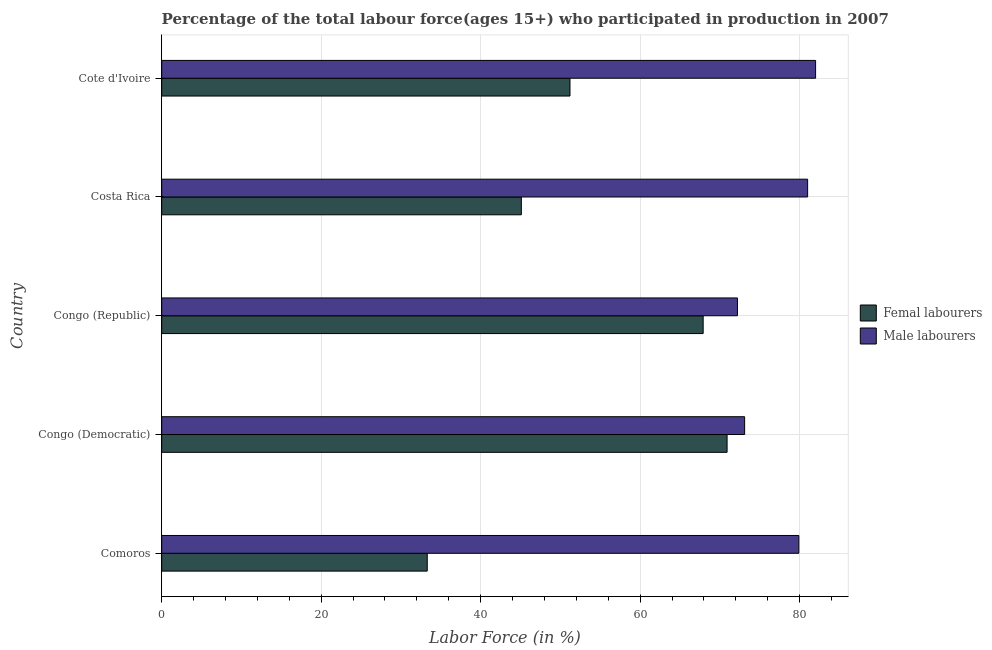How many groups of bars are there?
Keep it short and to the point. 5. Are the number of bars per tick equal to the number of legend labels?
Provide a succinct answer. Yes. How many bars are there on the 1st tick from the top?
Provide a succinct answer. 2. How many bars are there on the 3rd tick from the bottom?
Your answer should be very brief. 2. What is the label of the 2nd group of bars from the top?
Make the answer very short. Costa Rica. In how many cases, is the number of bars for a given country not equal to the number of legend labels?
Keep it short and to the point. 0. What is the percentage of female labor force in Comoros?
Your answer should be compact. 33.3. Across all countries, what is the maximum percentage of male labour force?
Your answer should be very brief. 82. Across all countries, what is the minimum percentage of male labour force?
Give a very brief answer. 72.2. In which country was the percentage of male labour force maximum?
Make the answer very short. Cote d'Ivoire. In which country was the percentage of male labour force minimum?
Give a very brief answer. Congo (Republic). What is the total percentage of male labour force in the graph?
Give a very brief answer. 388.2. What is the difference between the percentage of female labor force in Comoros and that in Congo (Republic)?
Make the answer very short. -34.6. What is the difference between the percentage of male labour force in Congo (Democratic) and the percentage of female labor force in Congo (Republic)?
Offer a very short reply. 5.2. What is the average percentage of male labour force per country?
Keep it short and to the point. 77.64. What is the difference between the percentage of male labour force and percentage of female labor force in Congo (Republic)?
Ensure brevity in your answer.  4.3. Is the percentage of female labor force in Comoros less than that in Congo (Democratic)?
Keep it short and to the point. Yes. Is the difference between the percentage of female labor force in Comoros and Congo (Republic) greater than the difference between the percentage of male labour force in Comoros and Congo (Republic)?
Offer a terse response. No. In how many countries, is the percentage of female labor force greater than the average percentage of female labor force taken over all countries?
Provide a succinct answer. 2. What does the 1st bar from the top in Cote d'Ivoire represents?
Keep it short and to the point. Male labourers. What does the 1st bar from the bottom in Congo (Democratic) represents?
Offer a terse response. Femal labourers. How many bars are there?
Your response must be concise. 10. Are all the bars in the graph horizontal?
Provide a succinct answer. Yes. What is the difference between two consecutive major ticks on the X-axis?
Offer a very short reply. 20. Does the graph contain grids?
Offer a terse response. Yes. How are the legend labels stacked?
Your response must be concise. Vertical. What is the title of the graph?
Offer a terse response. Percentage of the total labour force(ages 15+) who participated in production in 2007. Does "Canada" appear as one of the legend labels in the graph?
Offer a terse response. No. What is the label or title of the Y-axis?
Your answer should be very brief. Country. What is the Labor Force (in %) in Femal labourers in Comoros?
Give a very brief answer. 33.3. What is the Labor Force (in %) of Male labourers in Comoros?
Make the answer very short. 79.9. What is the Labor Force (in %) in Femal labourers in Congo (Democratic)?
Give a very brief answer. 70.9. What is the Labor Force (in %) of Male labourers in Congo (Democratic)?
Your answer should be very brief. 73.1. What is the Labor Force (in %) in Femal labourers in Congo (Republic)?
Offer a very short reply. 67.9. What is the Labor Force (in %) of Male labourers in Congo (Republic)?
Your response must be concise. 72.2. What is the Labor Force (in %) in Femal labourers in Costa Rica?
Ensure brevity in your answer.  45.1. What is the Labor Force (in %) in Male labourers in Costa Rica?
Your response must be concise. 81. What is the Labor Force (in %) of Femal labourers in Cote d'Ivoire?
Provide a short and direct response. 51.2. Across all countries, what is the maximum Labor Force (in %) in Femal labourers?
Your answer should be compact. 70.9. Across all countries, what is the maximum Labor Force (in %) of Male labourers?
Your answer should be very brief. 82. Across all countries, what is the minimum Labor Force (in %) of Femal labourers?
Make the answer very short. 33.3. Across all countries, what is the minimum Labor Force (in %) in Male labourers?
Your response must be concise. 72.2. What is the total Labor Force (in %) in Femal labourers in the graph?
Your response must be concise. 268.4. What is the total Labor Force (in %) of Male labourers in the graph?
Offer a terse response. 388.2. What is the difference between the Labor Force (in %) of Femal labourers in Comoros and that in Congo (Democratic)?
Offer a terse response. -37.6. What is the difference between the Labor Force (in %) in Male labourers in Comoros and that in Congo (Democratic)?
Provide a succinct answer. 6.8. What is the difference between the Labor Force (in %) of Femal labourers in Comoros and that in Congo (Republic)?
Provide a succinct answer. -34.6. What is the difference between the Labor Force (in %) of Male labourers in Comoros and that in Congo (Republic)?
Ensure brevity in your answer.  7.7. What is the difference between the Labor Force (in %) in Femal labourers in Comoros and that in Cote d'Ivoire?
Make the answer very short. -17.9. What is the difference between the Labor Force (in %) in Male labourers in Congo (Democratic) and that in Congo (Republic)?
Ensure brevity in your answer.  0.9. What is the difference between the Labor Force (in %) of Femal labourers in Congo (Democratic) and that in Costa Rica?
Make the answer very short. 25.8. What is the difference between the Labor Force (in %) of Male labourers in Congo (Democratic) and that in Costa Rica?
Provide a succinct answer. -7.9. What is the difference between the Labor Force (in %) in Male labourers in Congo (Democratic) and that in Cote d'Ivoire?
Offer a very short reply. -8.9. What is the difference between the Labor Force (in %) of Femal labourers in Congo (Republic) and that in Costa Rica?
Provide a short and direct response. 22.8. What is the difference between the Labor Force (in %) of Male labourers in Congo (Republic) and that in Costa Rica?
Ensure brevity in your answer.  -8.8. What is the difference between the Labor Force (in %) in Male labourers in Congo (Republic) and that in Cote d'Ivoire?
Offer a terse response. -9.8. What is the difference between the Labor Force (in %) of Femal labourers in Costa Rica and that in Cote d'Ivoire?
Offer a terse response. -6.1. What is the difference between the Labor Force (in %) of Femal labourers in Comoros and the Labor Force (in %) of Male labourers in Congo (Democratic)?
Your answer should be compact. -39.8. What is the difference between the Labor Force (in %) in Femal labourers in Comoros and the Labor Force (in %) in Male labourers in Congo (Republic)?
Your answer should be very brief. -38.9. What is the difference between the Labor Force (in %) in Femal labourers in Comoros and the Labor Force (in %) in Male labourers in Costa Rica?
Your answer should be very brief. -47.7. What is the difference between the Labor Force (in %) of Femal labourers in Comoros and the Labor Force (in %) of Male labourers in Cote d'Ivoire?
Your answer should be very brief. -48.7. What is the difference between the Labor Force (in %) of Femal labourers in Congo (Democratic) and the Labor Force (in %) of Male labourers in Congo (Republic)?
Give a very brief answer. -1.3. What is the difference between the Labor Force (in %) in Femal labourers in Congo (Democratic) and the Labor Force (in %) in Male labourers in Cote d'Ivoire?
Give a very brief answer. -11.1. What is the difference between the Labor Force (in %) of Femal labourers in Congo (Republic) and the Labor Force (in %) of Male labourers in Costa Rica?
Make the answer very short. -13.1. What is the difference between the Labor Force (in %) of Femal labourers in Congo (Republic) and the Labor Force (in %) of Male labourers in Cote d'Ivoire?
Offer a very short reply. -14.1. What is the difference between the Labor Force (in %) in Femal labourers in Costa Rica and the Labor Force (in %) in Male labourers in Cote d'Ivoire?
Offer a terse response. -36.9. What is the average Labor Force (in %) in Femal labourers per country?
Offer a terse response. 53.68. What is the average Labor Force (in %) of Male labourers per country?
Provide a short and direct response. 77.64. What is the difference between the Labor Force (in %) of Femal labourers and Labor Force (in %) of Male labourers in Comoros?
Offer a very short reply. -46.6. What is the difference between the Labor Force (in %) in Femal labourers and Labor Force (in %) in Male labourers in Congo (Democratic)?
Your response must be concise. -2.2. What is the difference between the Labor Force (in %) of Femal labourers and Labor Force (in %) of Male labourers in Costa Rica?
Make the answer very short. -35.9. What is the difference between the Labor Force (in %) of Femal labourers and Labor Force (in %) of Male labourers in Cote d'Ivoire?
Make the answer very short. -30.8. What is the ratio of the Labor Force (in %) of Femal labourers in Comoros to that in Congo (Democratic)?
Provide a succinct answer. 0.47. What is the ratio of the Labor Force (in %) of Male labourers in Comoros to that in Congo (Democratic)?
Ensure brevity in your answer.  1.09. What is the ratio of the Labor Force (in %) of Femal labourers in Comoros to that in Congo (Republic)?
Give a very brief answer. 0.49. What is the ratio of the Labor Force (in %) in Male labourers in Comoros to that in Congo (Republic)?
Your response must be concise. 1.11. What is the ratio of the Labor Force (in %) of Femal labourers in Comoros to that in Costa Rica?
Provide a succinct answer. 0.74. What is the ratio of the Labor Force (in %) of Male labourers in Comoros to that in Costa Rica?
Make the answer very short. 0.99. What is the ratio of the Labor Force (in %) in Femal labourers in Comoros to that in Cote d'Ivoire?
Offer a terse response. 0.65. What is the ratio of the Labor Force (in %) of Male labourers in Comoros to that in Cote d'Ivoire?
Keep it short and to the point. 0.97. What is the ratio of the Labor Force (in %) of Femal labourers in Congo (Democratic) to that in Congo (Republic)?
Your answer should be very brief. 1.04. What is the ratio of the Labor Force (in %) of Male labourers in Congo (Democratic) to that in Congo (Republic)?
Your response must be concise. 1.01. What is the ratio of the Labor Force (in %) of Femal labourers in Congo (Democratic) to that in Costa Rica?
Keep it short and to the point. 1.57. What is the ratio of the Labor Force (in %) of Male labourers in Congo (Democratic) to that in Costa Rica?
Your response must be concise. 0.9. What is the ratio of the Labor Force (in %) in Femal labourers in Congo (Democratic) to that in Cote d'Ivoire?
Keep it short and to the point. 1.38. What is the ratio of the Labor Force (in %) of Male labourers in Congo (Democratic) to that in Cote d'Ivoire?
Your answer should be very brief. 0.89. What is the ratio of the Labor Force (in %) in Femal labourers in Congo (Republic) to that in Costa Rica?
Keep it short and to the point. 1.51. What is the ratio of the Labor Force (in %) in Male labourers in Congo (Republic) to that in Costa Rica?
Your answer should be very brief. 0.89. What is the ratio of the Labor Force (in %) of Femal labourers in Congo (Republic) to that in Cote d'Ivoire?
Offer a very short reply. 1.33. What is the ratio of the Labor Force (in %) of Male labourers in Congo (Republic) to that in Cote d'Ivoire?
Give a very brief answer. 0.88. What is the ratio of the Labor Force (in %) of Femal labourers in Costa Rica to that in Cote d'Ivoire?
Keep it short and to the point. 0.88. What is the ratio of the Labor Force (in %) of Male labourers in Costa Rica to that in Cote d'Ivoire?
Keep it short and to the point. 0.99. What is the difference between the highest and the second highest Labor Force (in %) of Male labourers?
Give a very brief answer. 1. What is the difference between the highest and the lowest Labor Force (in %) in Femal labourers?
Provide a succinct answer. 37.6. What is the difference between the highest and the lowest Labor Force (in %) in Male labourers?
Provide a short and direct response. 9.8. 